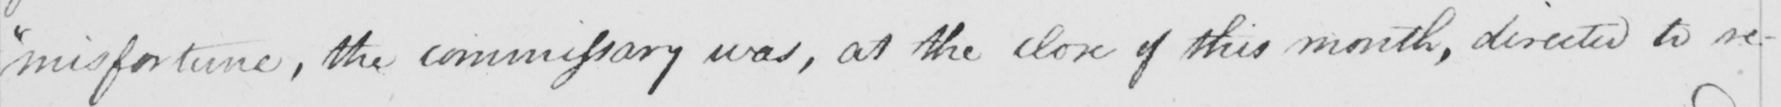Can you tell me what this handwritten text says? misfortune , the commissary was , at the close of this month , directed to re- 